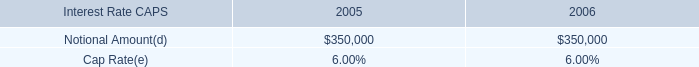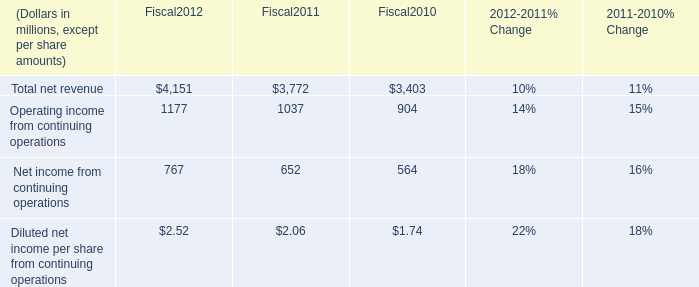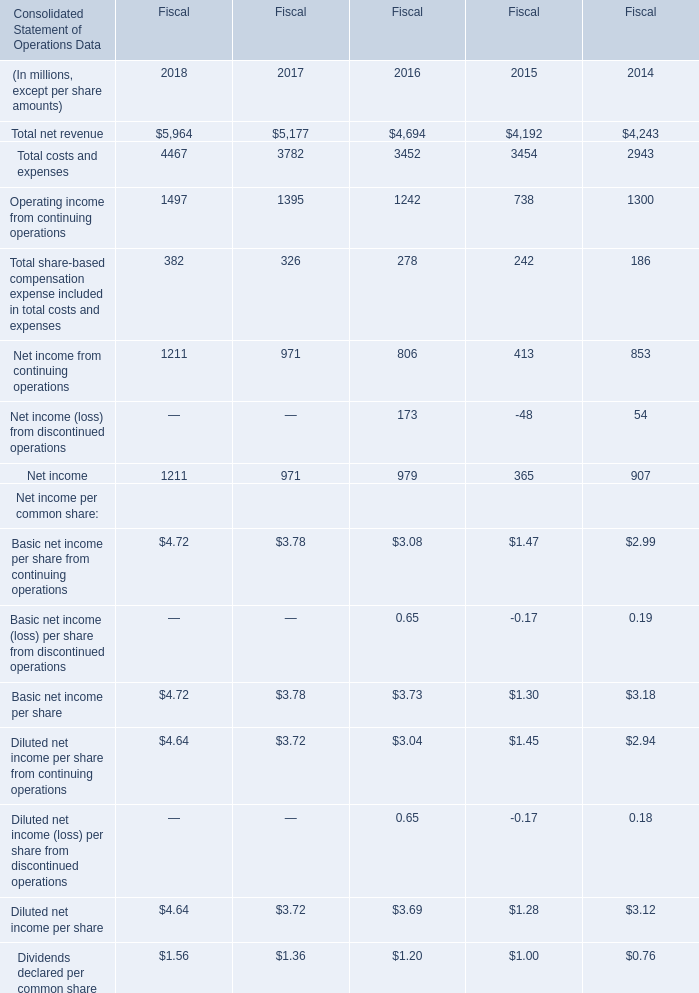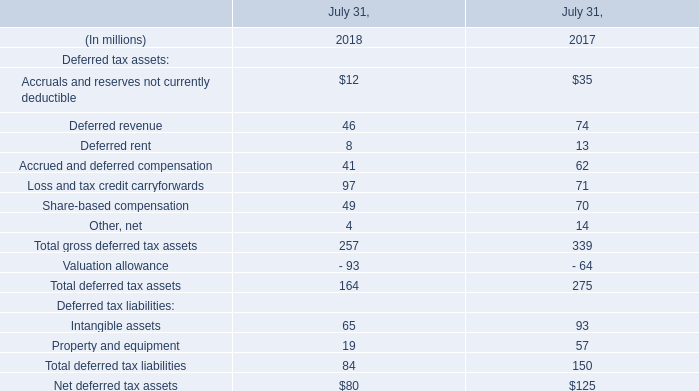What's the sum of Operating income from continuing operations of Fiscal2011, Net income of Fiscal 2018, and Total costs and expenses of Fiscal 2014 ? 
Computations: ((1037.0 + 1211.0) + 2943.0)
Answer: 5191.0. 